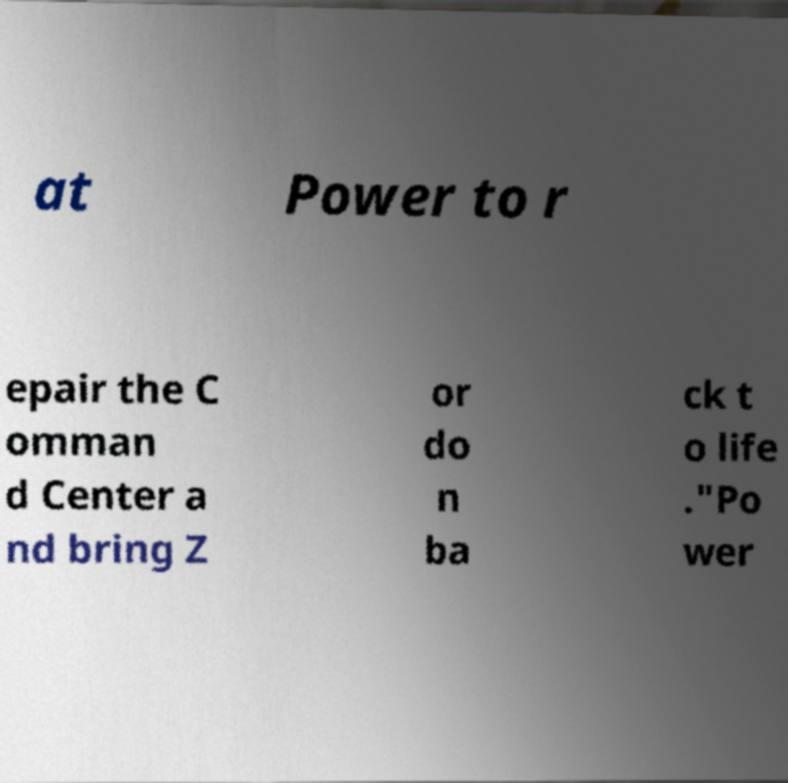There's text embedded in this image that I need extracted. Can you transcribe it verbatim? at Power to r epair the C omman d Center a nd bring Z or do n ba ck t o life ."Po wer 